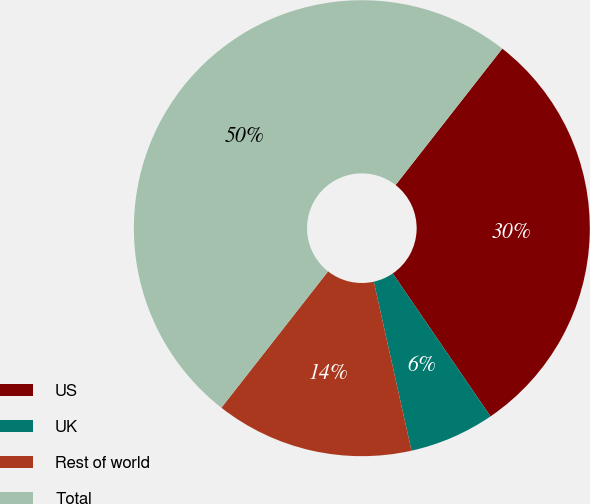Convert chart. <chart><loc_0><loc_0><loc_500><loc_500><pie_chart><fcel>US<fcel>UK<fcel>Rest of world<fcel>Total<nl><fcel>29.89%<fcel>6.05%<fcel>14.06%<fcel>50.0%<nl></chart> 